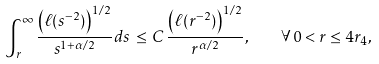<formula> <loc_0><loc_0><loc_500><loc_500>\int ^ { \infty } _ { r } \frac { \left ( \ell ( s ^ { - 2 } ) \right ) ^ { 1 / 2 } } { s ^ { 1 + \alpha / 2 } } d s \, \leq \, C \, \frac { \left ( \ell ( r ^ { - 2 } ) \right ) ^ { 1 / 2 } } { r ^ { \alpha / 2 } } , \quad \forall \, 0 < r \leq 4 r _ { 4 } ,</formula> 